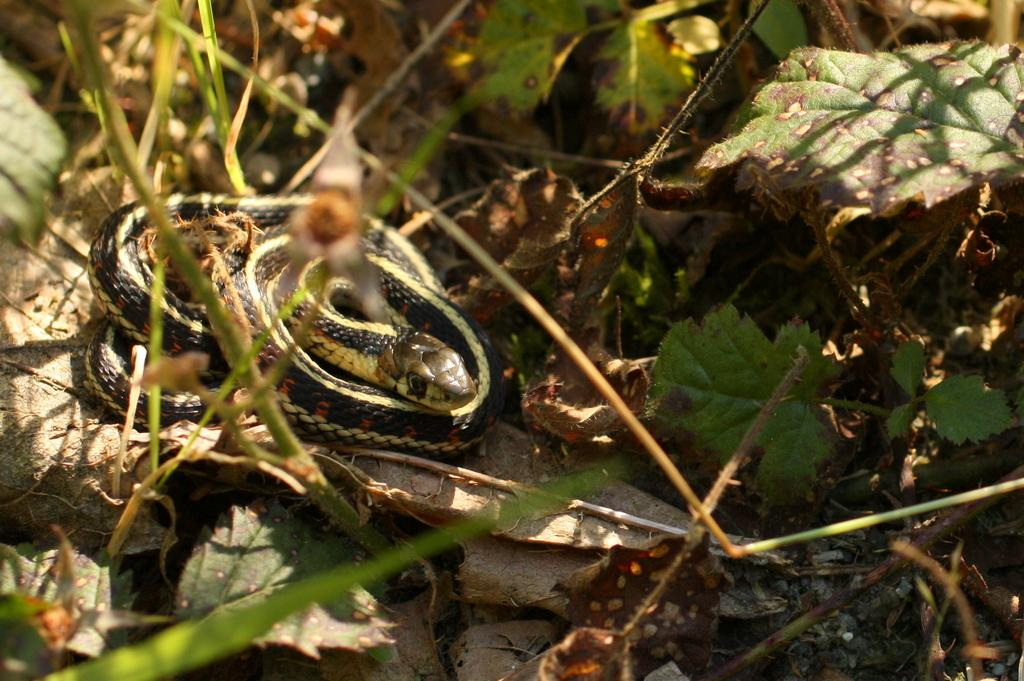What type of animal is in the picture? There is a snake in the picture. Can you describe the color of the snake? The snake is black and yellow in color. What else can be seen in the picture besides the snake? There are leaves and plants in the picture. What type of zinc system is being used in the picture? There is no mention of a zinc system in the picture; it features a snake and plants. 